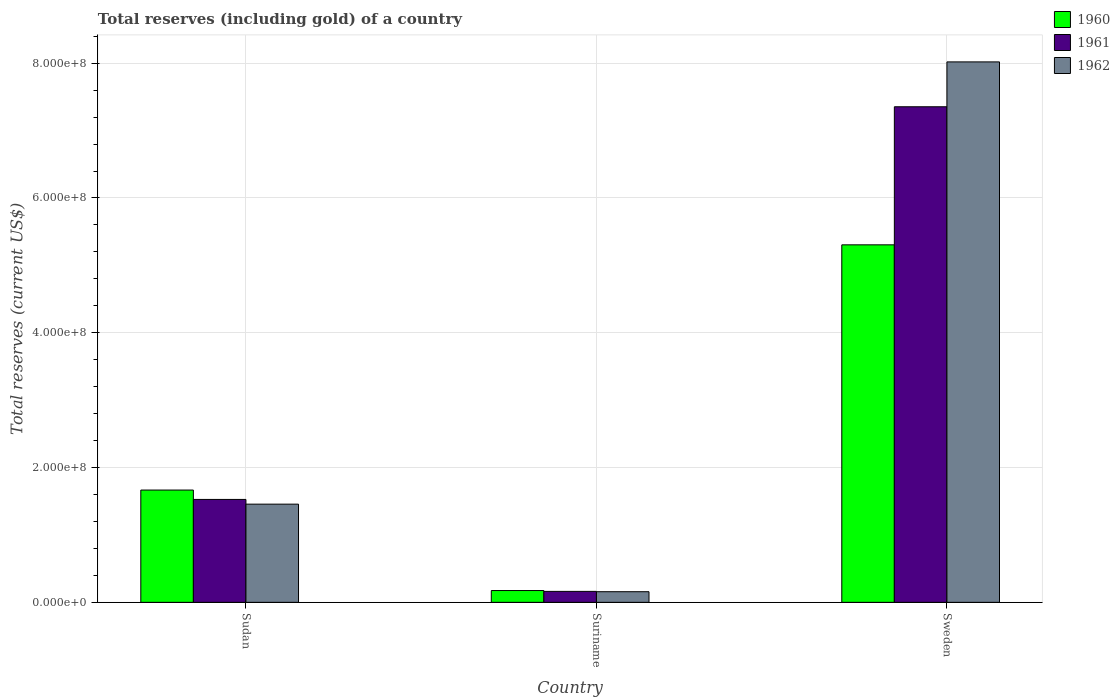How many groups of bars are there?
Your answer should be very brief. 3. Are the number of bars on each tick of the X-axis equal?
Provide a succinct answer. Yes. How many bars are there on the 2nd tick from the left?
Your answer should be compact. 3. How many bars are there on the 1st tick from the right?
Keep it short and to the point. 3. What is the label of the 3rd group of bars from the left?
Make the answer very short. Sweden. In how many cases, is the number of bars for a given country not equal to the number of legend labels?
Give a very brief answer. 0. What is the total reserves (including gold) in 1960 in Sudan?
Provide a short and direct response. 1.67e+08. Across all countries, what is the maximum total reserves (including gold) in 1961?
Offer a terse response. 7.35e+08. Across all countries, what is the minimum total reserves (including gold) in 1961?
Make the answer very short. 1.63e+07. In which country was the total reserves (including gold) in 1961 maximum?
Keep it short and to the point. Sweden. In which country was the total reserves (including gold) in 1960 minimum?
Ensure brevity in your answer.  Suriname. What is the total total reserves (including gold) in 1962 in the graph?
Ensure brevity in your answer.  9.63e+08. What is the difference between the total reserves (including gold) in 1960 in Sudan and that in Sweden?
Offer a very short reply. -3.64e+08. What is the difference between the total reserves (including gold) in 1962 in Sweden and the total reserves (including gold) in 1960 in Suriname?
Make the answer very short. 7.84e+08. What is the average total reserves (including gold) in 1960 per country?
Your answer should be compact. 2.38e+08. What is the difference between the total reserves (including gold) of/in 1961 and total reserves (including gold) of/in 1960 in Sweden?
Give a very brief answer. 2.05e+08. What is the ratio of the total reserves (including gold) in 1962 in Suriname to that in Sweden?
Provide a short and direct response. 0.02. Is the total reserves (including gold) in 1960 in Sudan less than that in Sweden?
Offer a terse response. Yes. Is the difference between the total reserves (including gold) in 1961 in Sudan and Suriname greater than the difference between the total reserves (including gold) in 1960 in Sudan and Suriname?
Provide a succinct answer. No. What is the difference between the highest and the second highest total reserves (including gold) in 1961?
Make the answer very short. -5.83e+08. What is the difference between the highest and the lowest total reserves (including gold) in 1960?
Give a very brief answer. 5.13e+08. In how many countries, is the total reserves (including gold) in 1962 greater than the average total reserves (including gold) in 1962 taken over all countries?
Keep it short and to the point. 1. Is the sum of the total reserves (including gold) in 1960 in Sudan and Suriname greater than the maximum total reserves (including gold) in 1961 across all countries?
Provide a succinct answer. No. What does the 2nd bar from the right in Sudan represents?
Provide a succinct answer. 1961. Is it the case that in every country, the sum of the total reserves (including gold) in 1961 and total reserves (including gold) in 1962 is greater than the total reserves (including gold) in 1960?
Provide a succinct answer. Yes. How many bars are there?
Offer a very short reply. 9. What is the difference between two consecutive major ticks on the Y-axis?
Your answer should be very brief. 2.00e+08. Does the graph contain any zero values?
Provide a succinct answer. No. Where does the legend appear in the graph?
Offer a very short reply. Top right. How many legend labels are there?
Ensure brevity in your answer.  3. What is the title of the graph?
Keep it short and to the point. Total reserves (including gold) of a country. What is the label or title of the Y-axis?
Ensure brevity in your answer.  Total reserves (current US$). What is the Total reserves (current US$) of 1960 in Sudan?
Make the answer very short. 1.67e+08. What is the Total reserves (current US$) of 1961 in Sudan?
Offer a terse response. 1.53e+08. What is the Total reserves (current US$) in 1962 in Sudan?
Your answer should be compact. 1.46e+08. What is the Total reserves (current US$) of 1960 in Suriname?
Your answer should be compact. 1.75e+07. What is the Total reserves (current US$) in 1961 in Suriname?
Provide a succinct answer. 1.63e+07. What is the Total reserves (current US$) in 1962 in Suriname?
Ensure brevity in your answer.  1.58e+07. What is the Total reserves (current US$) of 1960 in Sweden?
Provide a short and direct response. 5.30e+08. What is the Total reserves (current US$) of 1961 in Sweden?
Your answer should be compact. 7.35e+08. What is the Total reserves (current US$) of 1962 in Sweden?
Your response must be concise. 8.02e+08. Across all countries, what is the maximum Total reserves (current US$) of 1960?
Your response must be concise. 5.30e+08. Across all countries, what is the maximum Total reserves (current US$) in 1961?
Offer a terse response. 7.35e+08. Across all countries, what is the maximum Total reserves (current US$) of 1962?
Keep it short and to the point. 8.02e+08. Across all countries, what is the minimum Total reserves (current US$) in 1960?
Your answer should be compact. 1.75e+07. Across all countries, what is the minimum Total reserves (current US$) of 1961?
Ensure brevity in your answer.  1.63e+07. Across all countries, what is the minimum Total reserves (current US$) in 1962?
Provide a short and direct response. 1.58e+07. What is the total Total reserves (current US$) of 1960 in the graph?
Your answer should be very brief. 7.15e+08. What is the total Total reserves (current US$) of 1961 in the graph?
Provide a short and direct response. 9.04e+08. What is the total Total reserves (current US$) of 1962 in the graph?
Ensure brevity in your answer.  9.63e+08. What is the difference between the Total reserves (current US$) of 1960 in Sudan and that in Suriname?
Give a very brief answer. 1.49e+08. What is the difference between the Total reserves (current US$) of 1961 in Sudan and that in Suriname?
Provide a succinct answer. 1.36e+08. What is the difference between the Total reserves (current US$) in 1962 in Sudan and that in Suriname?
Your response must be concise. 1.30e+08. What is the difference between the Total reserves (current US$) in 1960 in Sudan and that in Sweden?
Provide a short and direct response. -3.64e+08. What is the difference between the Total reserves (current US$) in 1961 in Sudan and that in Sweden?
Ensure brevity in your answer.  -5.83e+08. What is the difference between the Total reserves (current US$) of 1962 in Sudan and that in Sweden?
Provide a succinct answer. -6.56e+08. What is the difference between the Total reserves (current US$) of 1960 in Suriname and that in Sweden?
Keep it short and to the point. -5.13e+08. What is the difference between the Total reserves (current US$) in 1961 in Suriname and that in Sweden?
Provide a succinct answer. -7.19e+08. What is the difference between the Total reserves (current US$) of 1962 in Suriname and that in Sweden?
Your response must be concise. -7.86e+08. What is the difference between the Total reserves (current US$) of 1960 in Sudan and the Total reserves (current US$) of 1961 in Suriname?
Make the answer very short. 1.50e+08. What is the difference between the Total reserves (current US$) of 1960 in Sudan and the Total reserves (current US$) of 1962 in Suriname?
Your response must be concise. 1.51e+08. What is the difference between the Total reserves (current US$) in 1961 in Sudan and the Total reserves (current US$) in 1962 in Suriname?
Offer a terse response. 1.37e+08. What is the difference between the Total reserves (current US$) in 1960 in Sudan and the Total reserves (current US$) in 1961 in Sweden?
Your answer should be very brief. -5.69e+08. What is the difference between the Total reserves (current US$) in 1960 in Sudan and the Total reserves (current US$) in 1962 in Sweden?
Offer a terse response. -6.35e+08. What is the difference between the Total reserves (current US$) of 1961 in Sudan and the Total reserves (current US$) of 1962 in Sweden?
Give a very brief answer. -6.49e+08. What is the difference between the Total reserves (current US$) of 1960 in Suriname and the Total reserves (current US$) of 1961 in Sweden?
Ensure brevity in your answer.  -7.18e+08. What is the difference between the Total reserves (current US$) in 1960 in Suriname and the Total reserves (current US$) in 1962 in Sweden?
Offer a very short reply. -7.84e+08. What is the difference between the Total reserves (current US$) of 1961 in Suriname and the Total reserves (current US$) of 1962 in Sweden?
Ensure brevity in your answer.  -7.86e+08. What is the average Total reserves (current US$) in 1960 per country?
Provide a succinct answer. 2.38e+08. What is the average Total reserves (current US$) of 1961 per country?
Your response must be concise. 3.01e+08. What is the average Total reserves (current US$) of 1962 per country?
Provide a succinct answer. 3.21e+08. What is the difference between the Total reserves (current US$) of 1960 and Total reserves (current US$) of 1961 in Sudan?
Make the answer very short. 1.39e+07. What is the difference between the Total reserves (current US$) in 1960 and Total reserves (current US$) in 1962 in Sudan?
Provide a succinct answer. 2.09e+07. What is the difference between the Total reserves (current US$) in 1961 and Total reserves (current US$) in 1962 in Sudan?
Offer a terse response. 7.00e+06. What is the difference between the Total reserves (current US$) of 1960 and Total reserves (current US$) of 1961 in Suriname?
Your response must be concise. 1.24e+06. What is the difference between the Total reserves (current US$) in 1960 and Total reserves (current US$) in 1962 in Suriname?
Your answer should be compact. 1.72e+06. What is the difference between the Total reserves (current US$) of 1961 and Total reserves (current US$) of 1962 in Suriname?
Keep it short and to the point. 4.83e+05. What is the difference between the Total reserves (current US$) of 1960 and Total reserves (current US$) of 1961 in Sweden?
Your answer should be compact. -2.05e+08. What is the difference between the Total reserves (current US$) in 1960 and Total reserves (current US$) in 1962 in Sweden?
Offer a terse response. -2.71e+08. What is the difference between the Total reserves (current US$) of 1961 and Total reserves (current US$) of 1962 in Sweden?
Give a very brief answer. -6.66e+07. What is the ratio of the Total reserves (current US$) of 1960 in Sudan to that in Suriname?
Your answer should be compact. 9.52. What is the ratio of the Total reserves (current US$) in 1961 in Sudan to that in Suriname?
Ensure brevity in your answer.  9.39. What is the ratio of the Total reserves (current US$) of 1962 in Sudan to that in Suriname?
Ensure brevity in your answer.  9.23. What is the ratio of the Total reserves (current US$) of 1960 in Sudan to that in Sweden?
Give a very brief answer. 0.31. What is the ratio of the Total reserves (current US$) in 1961 in Sudan to that in Sweden?
Your answer should be very brief. 0.21. What is the ratio of the Total reserves (current US$) of 1962 in Sudan to that in Sweden?
Provide a succinct answer. 0.18. What is the ratio of the Total reserves (current US$) of 1960 in Suriname to that in Sweden?
Keep it short and to the point. 0.03. What is the ratio of the Total reserves (current US$) of 1961 in Suriname to that in Sweden?
Provide a short and direct response. 0.02. What is the ratio of the Total reserves (current US$) in 1962 in Suriname to that in Sweden?
Offer a very short reply. 0.02. What is the difference between the highest and the second highest Total reserves (current US$) of 1960?
Ensure brevity in your answer.  3.64e+08. What is the difference between the highest and the second highest Total reserves (current US$) of 1961?
Offer a very short reply. 5.83e+08. What is the difference between the highest and the second highest Total reserves (current US$) in 1962?
Make the answer very short. 6.56e+08. What is the difference between the highest and the lowest Total reserves (current US$) in 1960?
Your answer should be compact. 5.13e+08. What is the difference between the highest and the lowest Total reserves (current US$) of 1961?
Offer a terse response. 7.19e+08. What is the difference between the highest and the lowest Total reserves (current US$) of 1962?
Your answer should be very brief. 7.86e+08. 